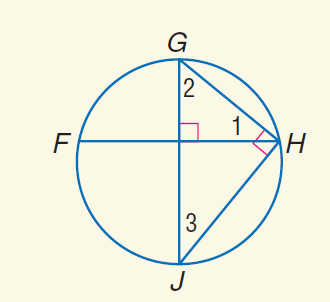Answer the mathemtical geometry problem and directly provide the correct option letter.
Question: m \widehat J H = 114. Find m \angle 1.
Choices: A: 23 B: 33 C: 66 D: 114 B 